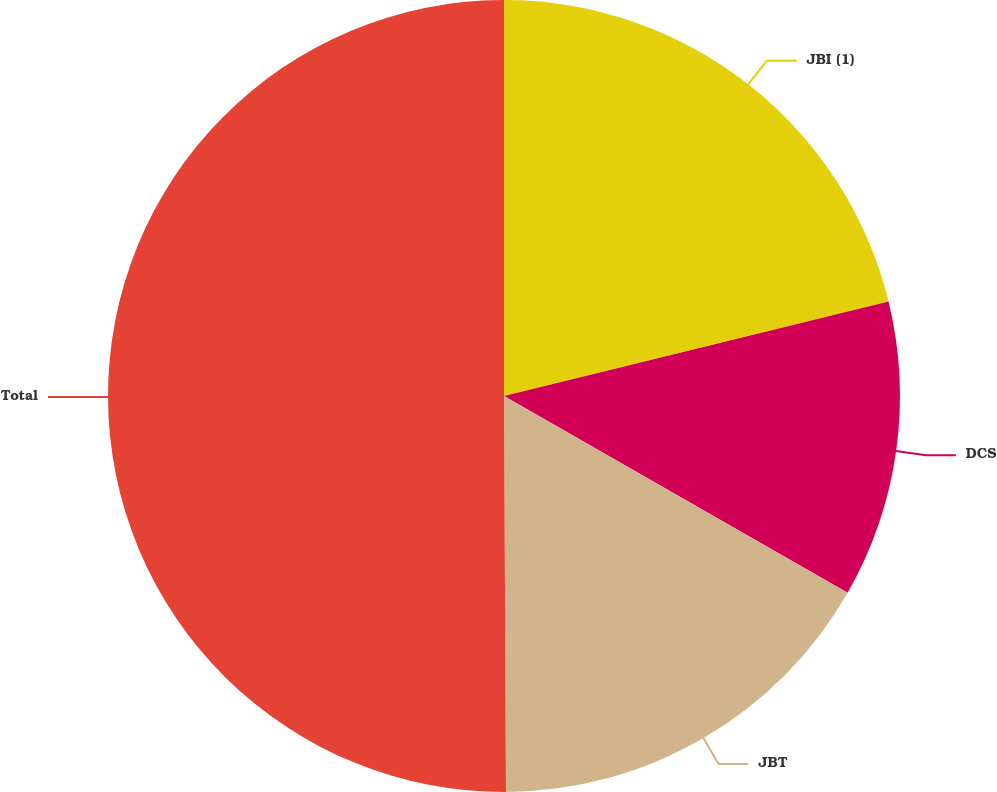<chart> <loc_0><loc_0><loc_500><loc_500><pie_chart><fcel>JBI (1)<fcel>DCS<fcel>JBT<fcel>Total<nl><fcel>21.16%<fcel>12.12%<fcel>16.64%<fcel>50.08%<nl></chart> 